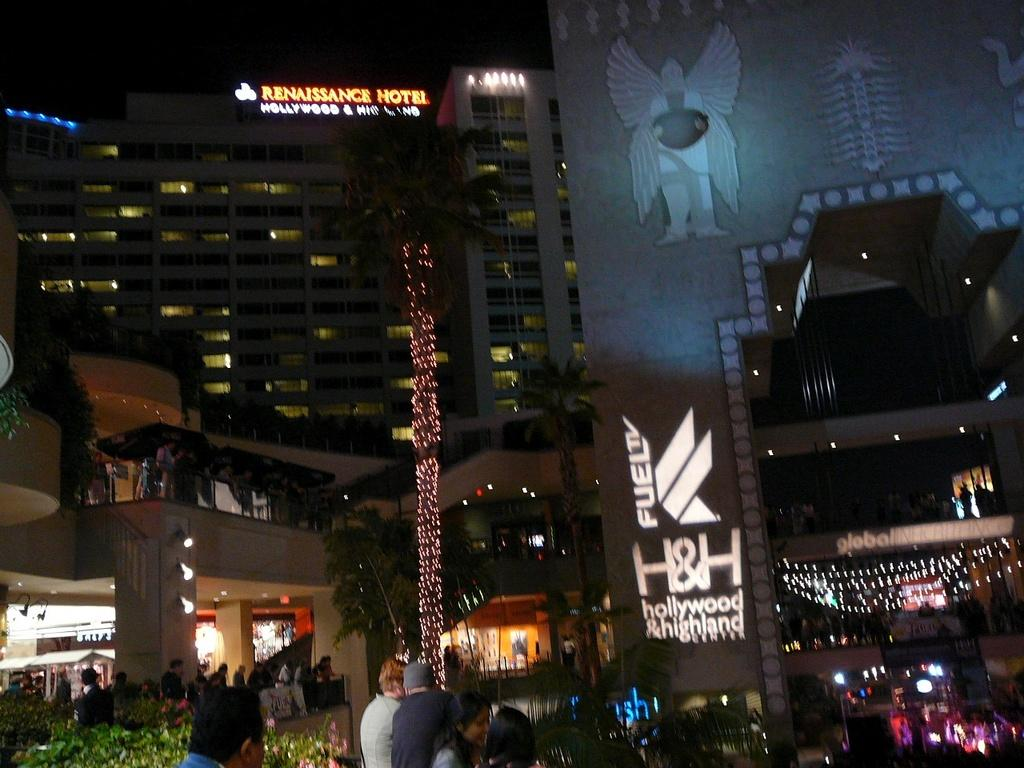What type of structures can be seen in the image? There are buildings in the image. What additional features are present in the image? Decor lights are visible in the image, and there are trees at the bottom of the image. Are there any people in the image? Yes, people are present in the image. What architectural element can be seen on the right side of the image? There is an arch on the right side of the image. What can be seen in the background of the image? The sky is visible in the background of the image. What type of badge is the governor wearing in the image? There is no governor or badge present in the image. How many cattle can be seen grazing in the image? There are no cattle present in the image. 